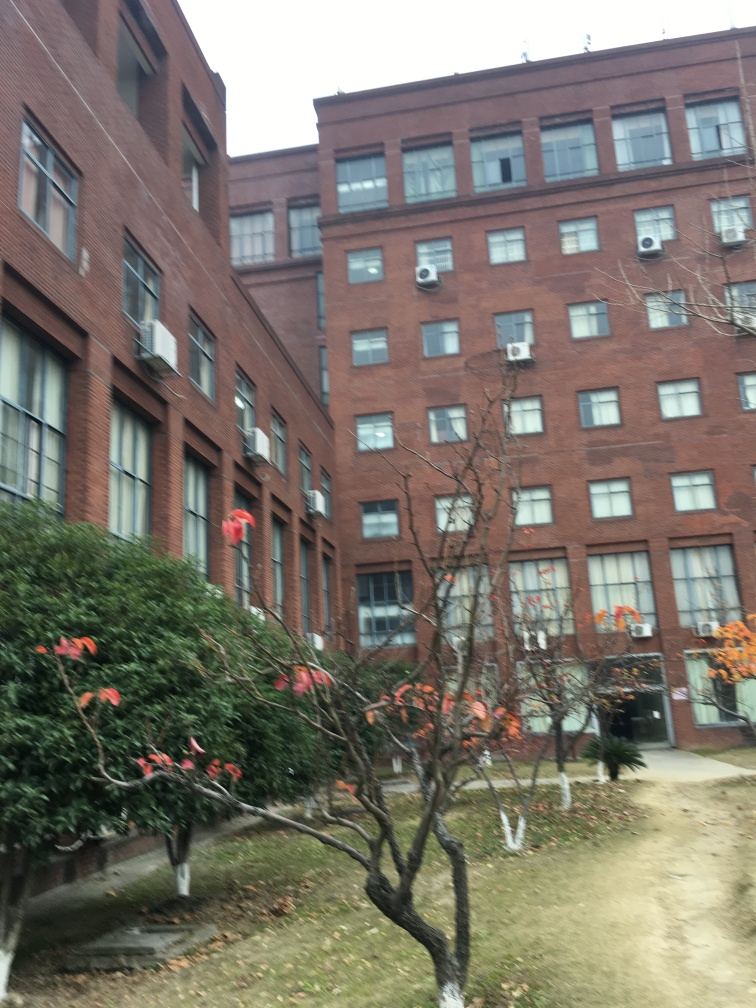Can you tell me what time of year it might be in this photo? Based on the leafless tree in the forefront and the absence of snow, it could be late autumn or early winter. The overcast sky and lack of foliage indicate it's definitely not summer. 